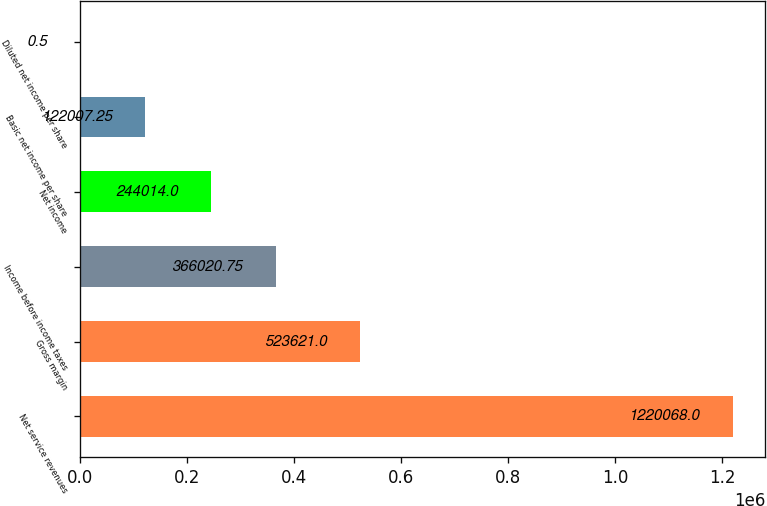Convert chart to OTSL. <chart><loc_0><loc_0><loc_500><loc_500><bar_chart><fcel>Net service revenues<fcel>Gross margin<fcel>Income before income taxes<fcel>Net income<fcel>Basic net income per share<fcel>Diluted net income per share<nl><fcel>1.22007e+06<fcel>523621<fcel>366021<fcel>244014<fcel>122007<fcel>0.5<nl></chart> 